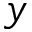<formula> <loc_0><loc_0><loc_500><loc_500>y</formula> 